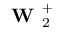<formula> <loc_0><loc_0><loc_500><loc_500>W _ { 2 } ^ { + }</formula> 